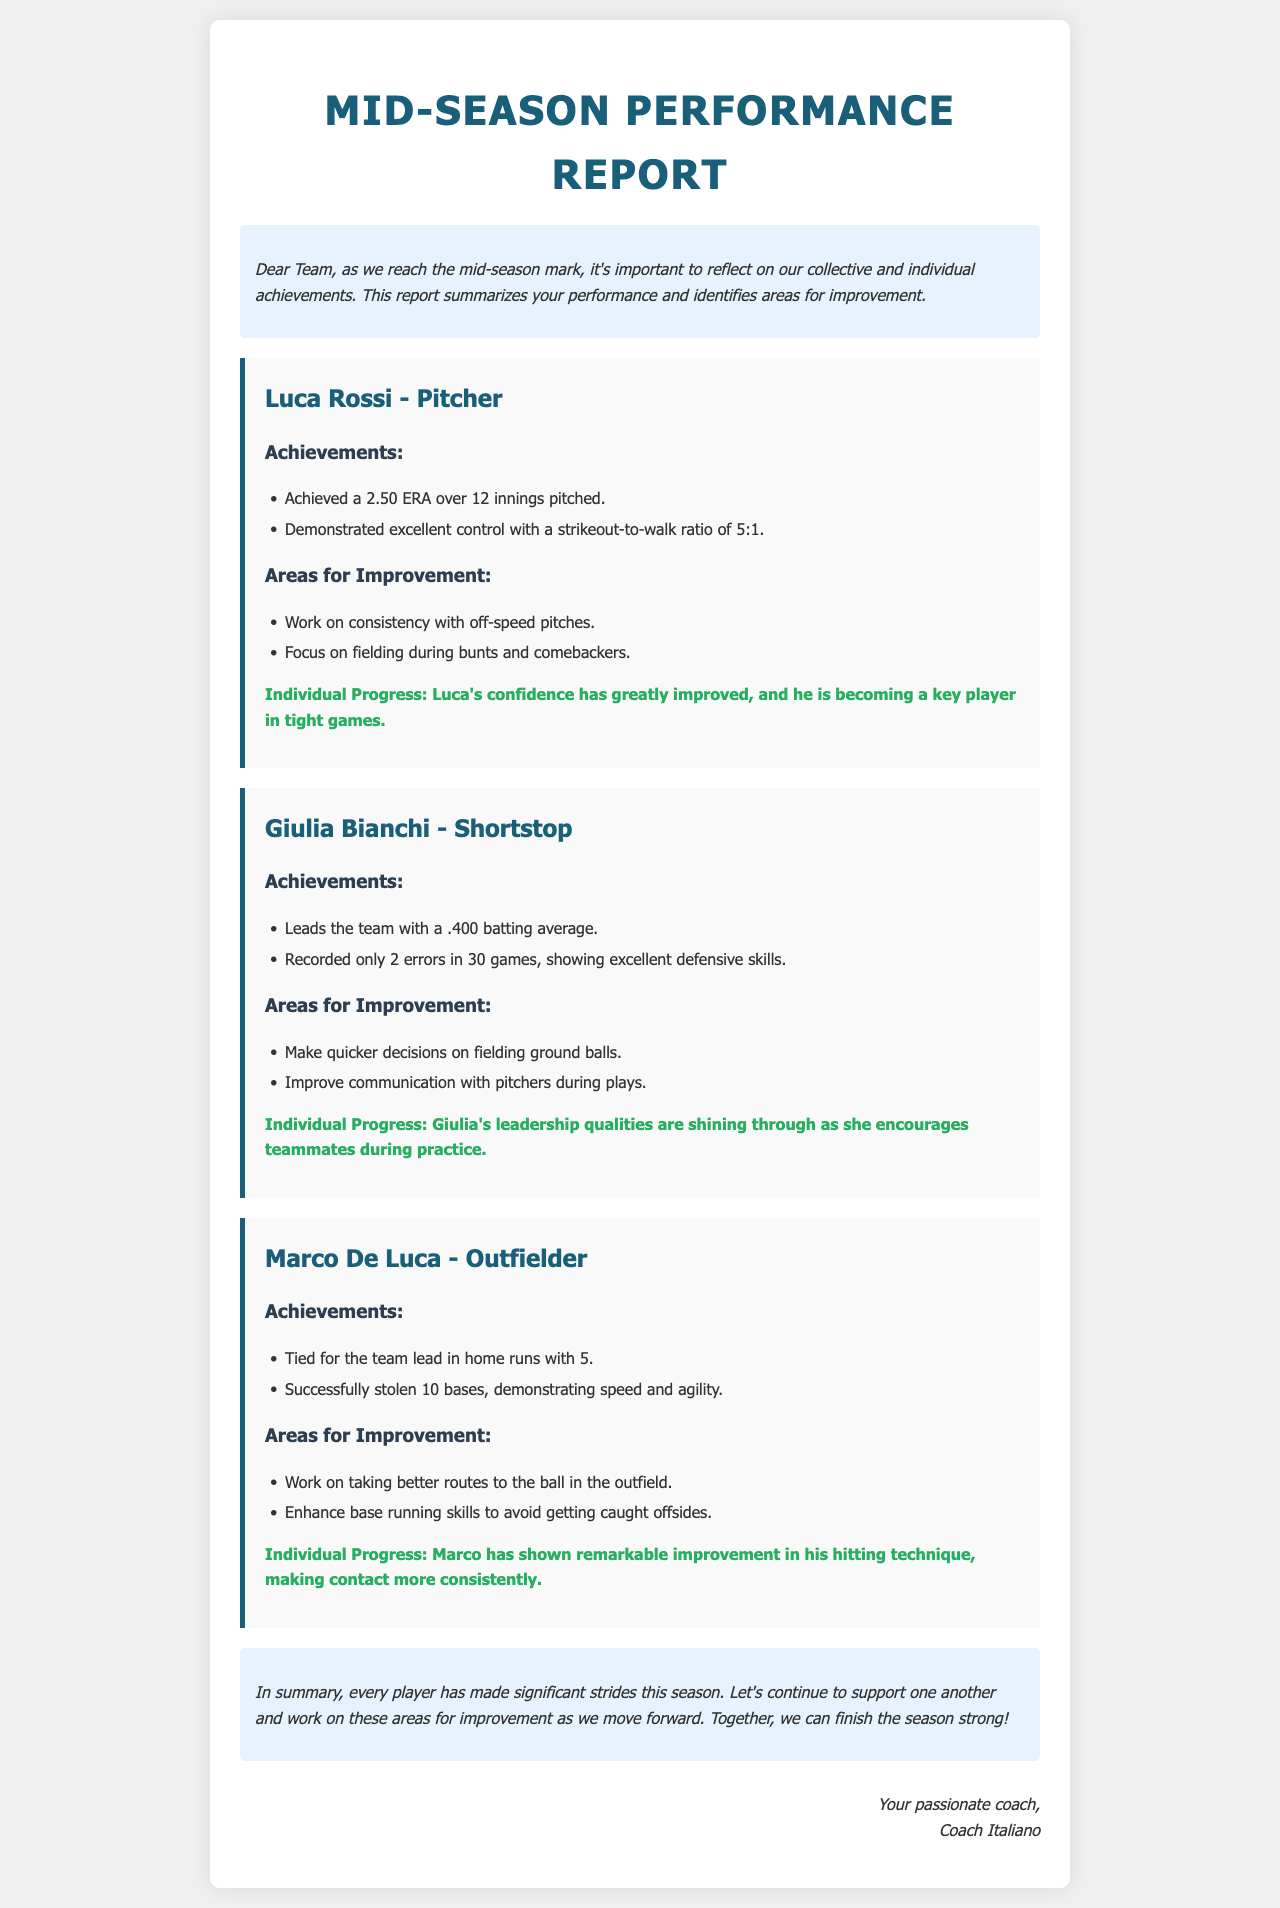What is Luca Rossi's ERA? Luca Rossi's ERA is mentioned in the achievements section, which is 2.50.
Answer: 2.50 How many home runs does Marco De Luca have? The report states that Marco De Luca is tied for the team lead in home runs with 5.
Answer: 5 What defensive achievement is highlighted for Giulia Bianchi? Giulia recorded only 2 errors in 30 games, showcasing her defensive skills.
Answer: 2 errors What skill does Marco need to improve in the outfield? The report specifies that Marco needs to work on taking better routes to the ball in the outfield.
Answer: Taking better routes Who is noted for showing leadership qualities? The report highlights Giulia Bianchi for her leadership qualities as she encourages teammates.
Answer: Giulia Bianchi What is the overall sentiment of the conclusion? The conclusion encourages continued support and improvement among players as the season progresses.
Answer: Support one another 